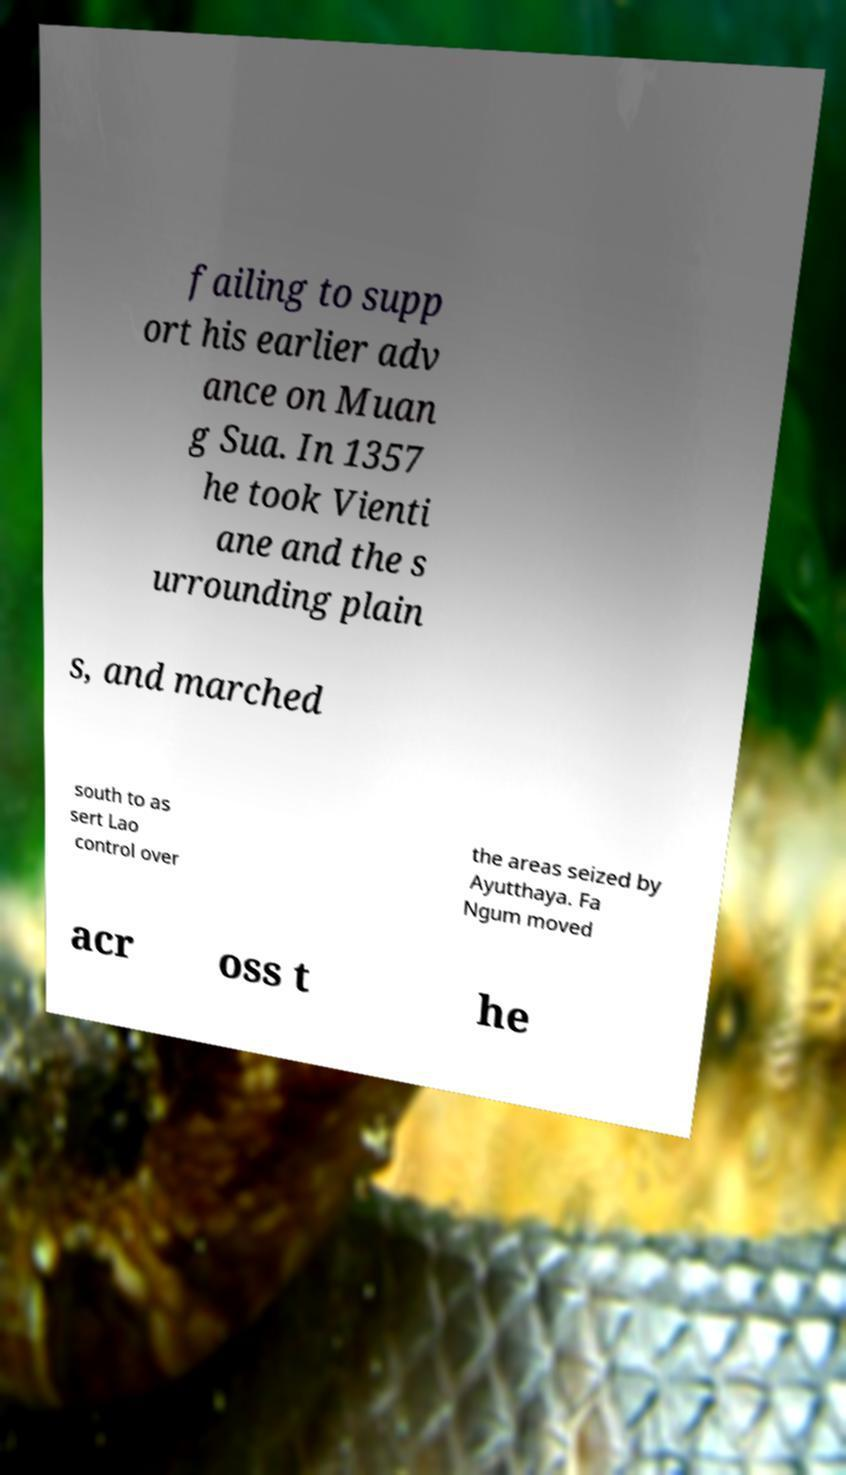Can you accurately transcribe the text from the provided image for me? failing to supp ort his earlier adv ance on Muan g Sua. In 1357 he took Vienti ane and the s urrounding plain s, and marched south to as sert Lao control over the areas seized by Ayutthaya. Fa Ngum moved acr oss t he 